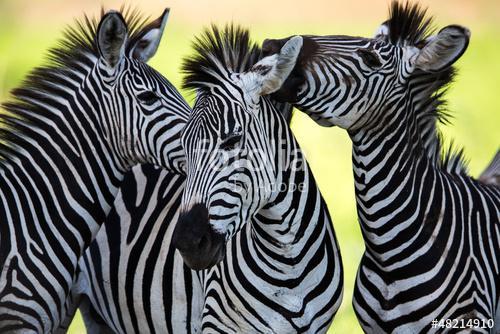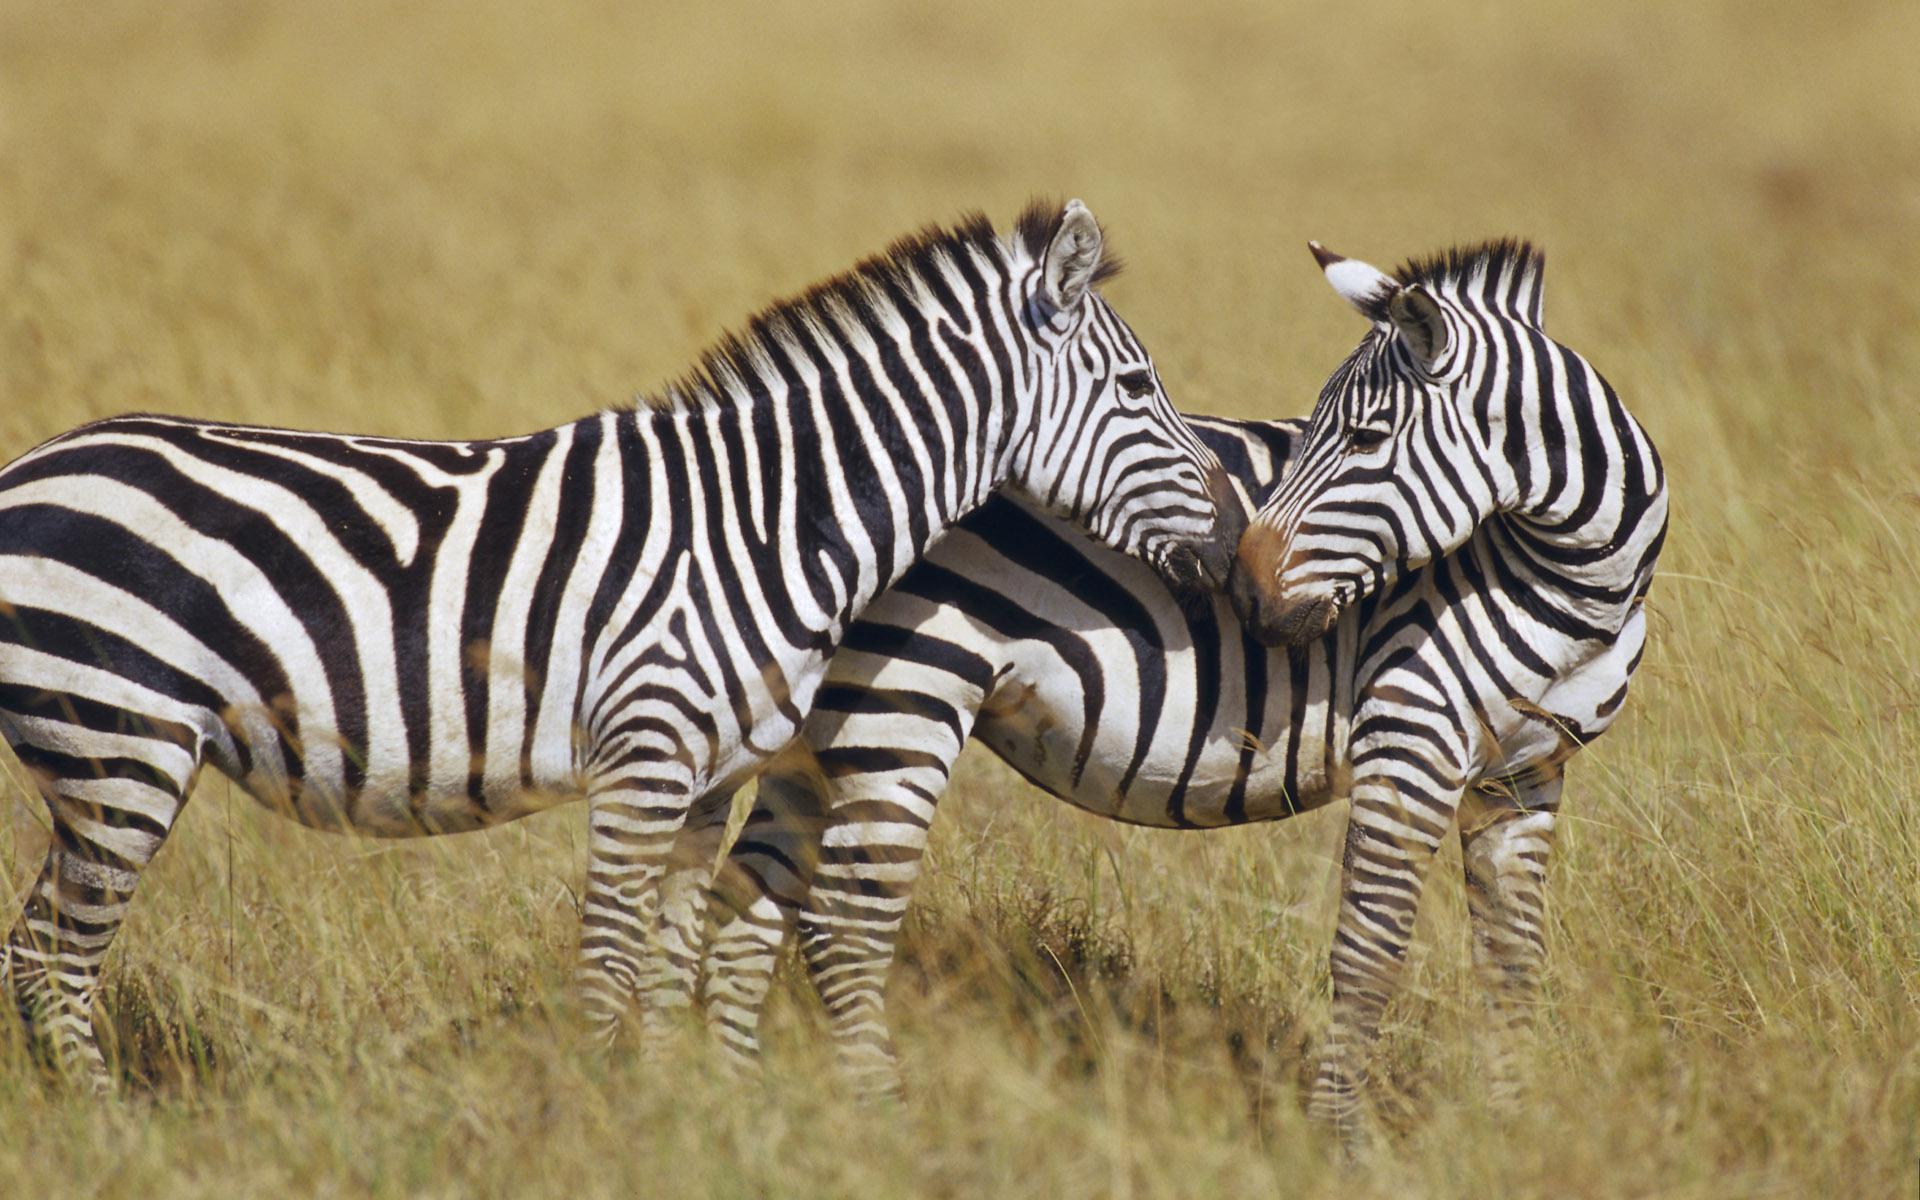The first image is the image on the left, the second image is the image on the right. Evaluate the accuracy of this statement regarding the images: "The left and right image contains the same number of zebras.". Is it true? Answer yes or no. No. The first image is the image on the left, the second image is the image on the right. Considering the images on both sides, is "The right image contains two zebras with their noses touching, and the left image contains three zebras, with two facing each other over the body of the one in the middle." valid? Answer yes or no. Yes. 